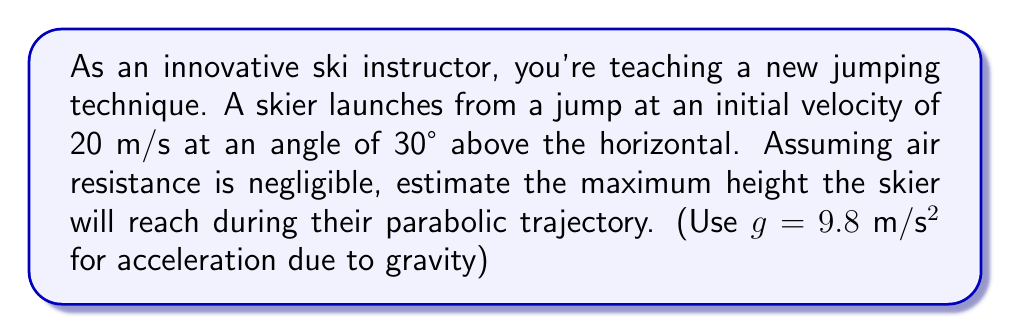Give your solution to this math problem. Let's approach this step-by-step:

1) The trajectory of the skier follows a parabolic path. The maximum height is reached when the vertical component of velocity becomes zero.

2) We can split the initial velocity into horizontal and vertical components:
   $v_x = v \cos \theta = 20 \cos 30° = 20 \cdot \frac{\sqrt{3}}{2} = 10\sqrt{3}$ m/s
   $v_y = v \sin \theta = 20 \sin 30° = 20 \cdot \frac{1}{2} = 10$ m/s

3) The time to reach the maximum height can be calculated using the equation:
   $$v_y = v_0 - gt$$
   Where $v_y = 0$ at the highest point, $v_0 = 10$ m/s, and $g = 9.8$ m/s²

4) Solving for t:
   $$0 = 10 - 9.8t$$
   $$t = \frac{10}{9.8} = 1.02$ seconds

5) Now we can use the equation for displacement to find the maximum height:
   $$y = v_0t - \frac{1}{2}gt^2$$

6) Substituting our values:
   $$y = 10 \cdot 1.02 - \frac{1}{2} \cdot 9.8 \cdot (1.02)^2$$
   $$y = 10.2 - 4.9 \cdot 1.0404$$
   $$y = 10.2 - 5.09796$$
   $$y = 5.10204$$ meters

Therefore, the maximum height reached by the skier is approximately 5.10 meters.

[asy]
import graph;
size(200,150);
real f(real x) {return -0.24*x^2 + 2.4*x;}
draw(graph(f,0,10));
draw((0,0)--(10,0),arrow=Arrow(TeXHead));
draw((0,0)--(0,6),arrow=Arrow(TeXHead));
label("x (m)",(10,0),E);
label("y (m)",(0,6),N);
dot((5,5.1));
label("Max Height",(5,5.1),NE);
[/asy]
Answer: The maximum height reached by the skier is approximately 5.10 meters. 